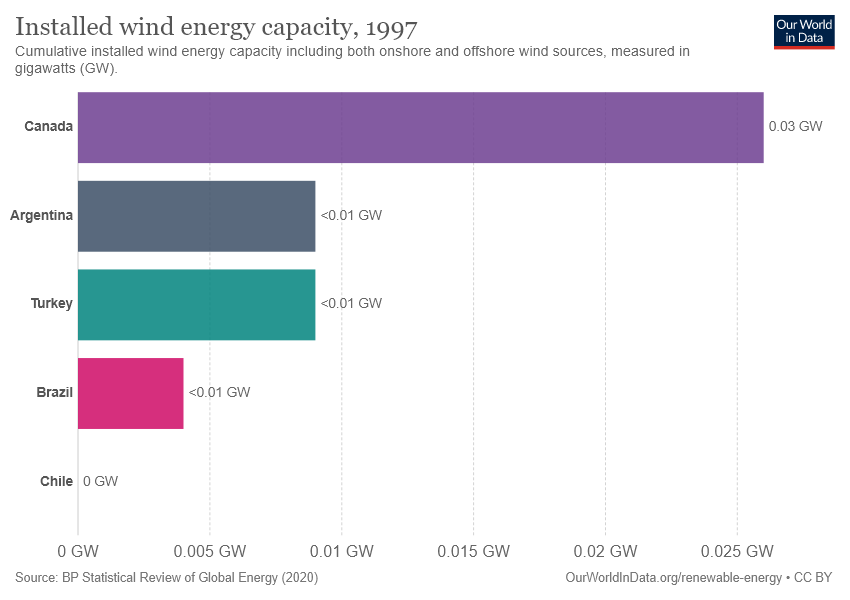Specify some key components in this picture. The total value of Brazil and Turkey is approximately 0.02. The value of Canada is approximately 0.03%. 